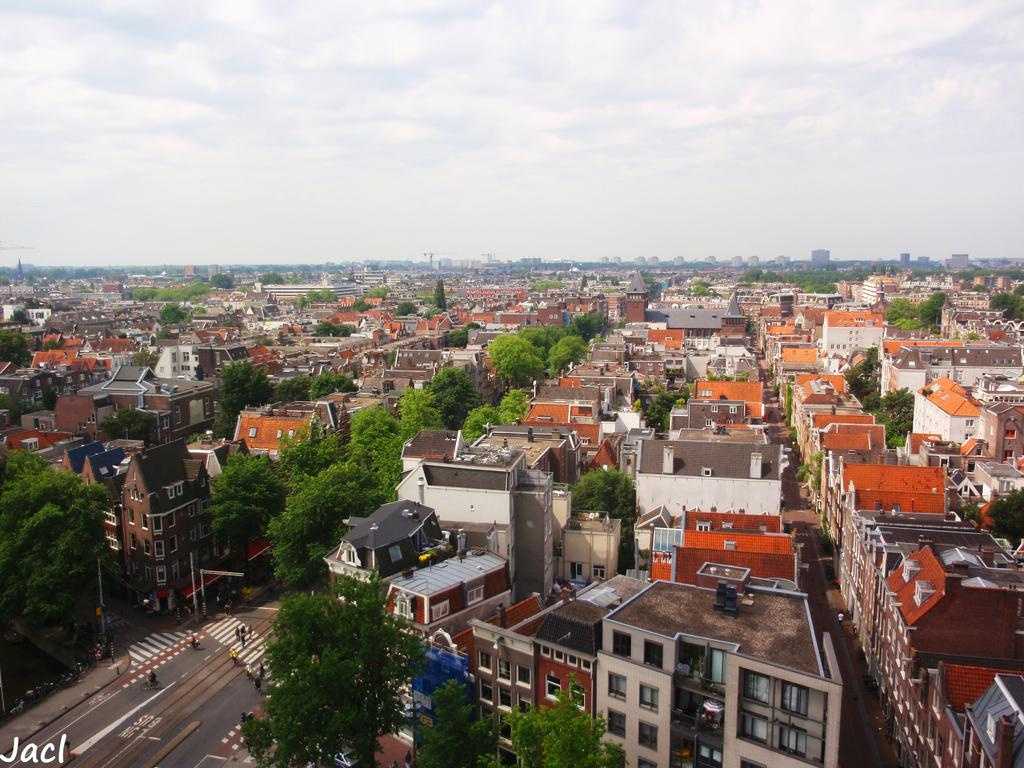What type of structures are visible in the image? There are houses and buildings in the image. Are there any living beings present in the image? Yes, there are people in the image. What can be seen connecting the different areas in the image? There are roads in the image. What are the tall, thin objects in the image? There are poles in the image. What is visible above the structures and people in the image? The sky is visible in the image. Can you see a crown on anyone's head in the image? There is no crown visible on anyone's head in the image. What sense is being used by the people in the image? The provided facts do not give information about the senses being used by the people in the image. 